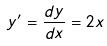<formula> <loc_0><loc_0><loc_500><loc_500>y ^ { \prime } = \frac { d y } { d x } = 2 x</formula> 